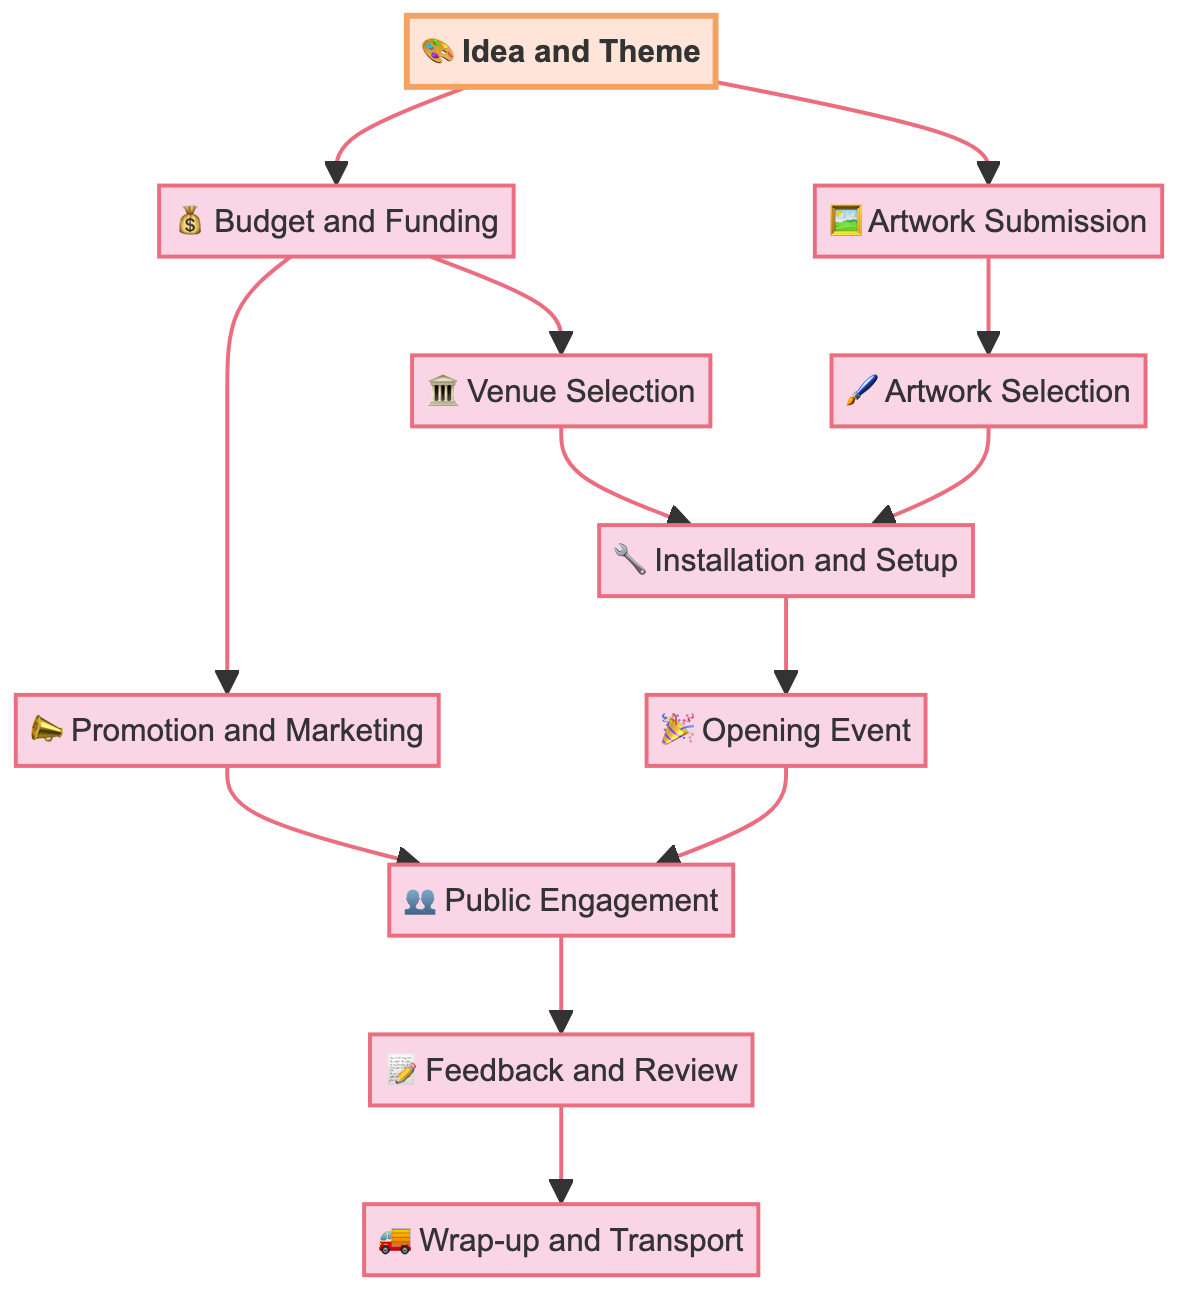What is the first action in the exhibition process? The diagram starts with the node "Idea and Theme," which indicates that developing an idea or theme is the first action taken in organizing the art exhibition.
Answer: Idea and Theme How many nodes are there in the diagram? Counting all the items listed in the 'nodes' section, there are 11 nodes representing different actions or decisions involved in setting up the exhibition.
Answer: 11 What is the final step in the exhibition setup? The last node in the flow of the diagram is "Wrap-up and Transport," which signifies that this is the concluding step of organizing the art exhibition.
Answer: Wrap-up and Transport Which two actions come after Budget and Funding? Based on the diagram, after "Budget and Funding," the subsequent actions are "Venue Selection" and "Promotion and Marketing," indicating both need to follow budget decisions.
Answer: Venue Selection, Promotion and Marketing Which action depends on both Artwork Submission and Budget and Funding? The node "Artwork Selection" follows from "Artwork Submission," which depends on the previous action of "Idea and Theme." Therefore, both "Artwork Submission" and "Budget and Funding" are prerequisites to reach "Artwork Selection."
Answer: Artwork Selection What is the connection between Opening Event and Public Engagement? The connection between these two nodes can be identified through a directed edge from "Opening Event" to "Public Engagement," indicating that the opening event leads directly to engaging with the public.
Answer: Opening Event leads to Public Engagement How many edges are there in the diagram? By examining the 'edges' section, we find there are 12 edges depicting the directed connections between the nodes in the diagram.
Answer: 12 What step follows Installation and Setup? The next step after "Installation and Setup," as per the directed flow, is the "Opening Event," marking the transition from preparations to the actual event.
Answer: Opening Event What action is needed for Public Engagement? The action required for "Public Engagement," as indicated in the diagram, is "Promotion and Marketing," which suggests that marketing efforts are essential to engage the public effectively.
Answer: Promotion and Marketing 